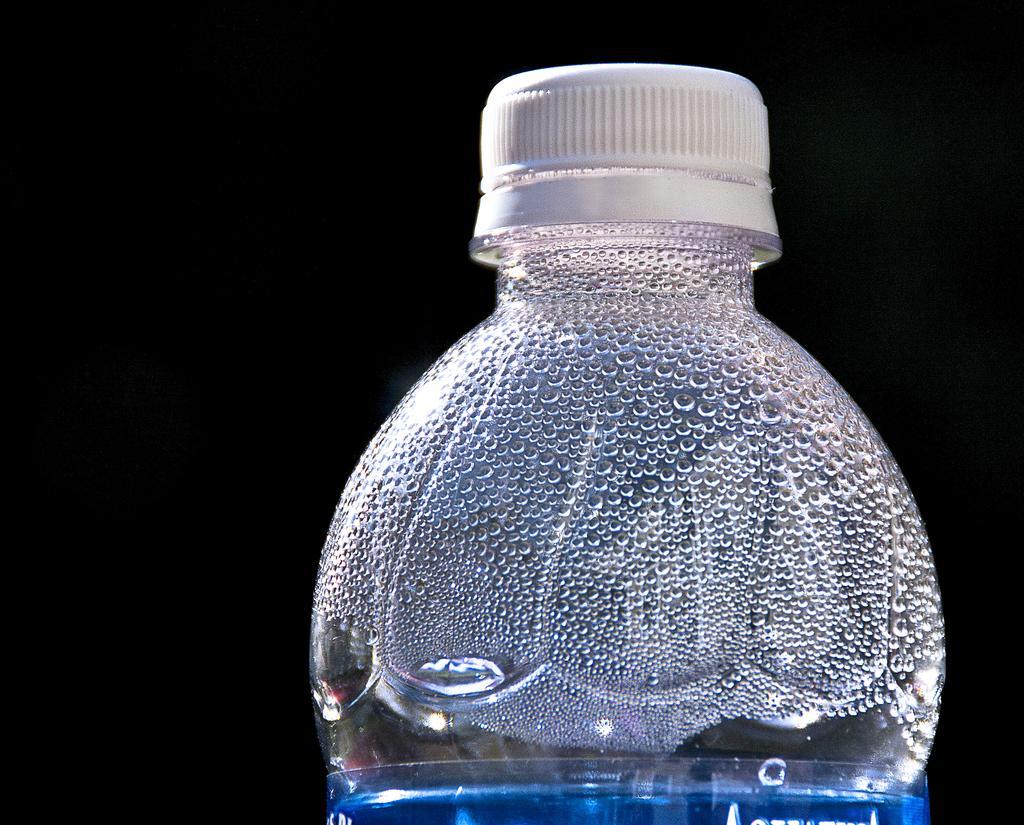Please provide a concise description of this image. There is a water bottle in this picture and there is a white cap and we observe few water droplets on the side of the water bottle. The background is black in color. 